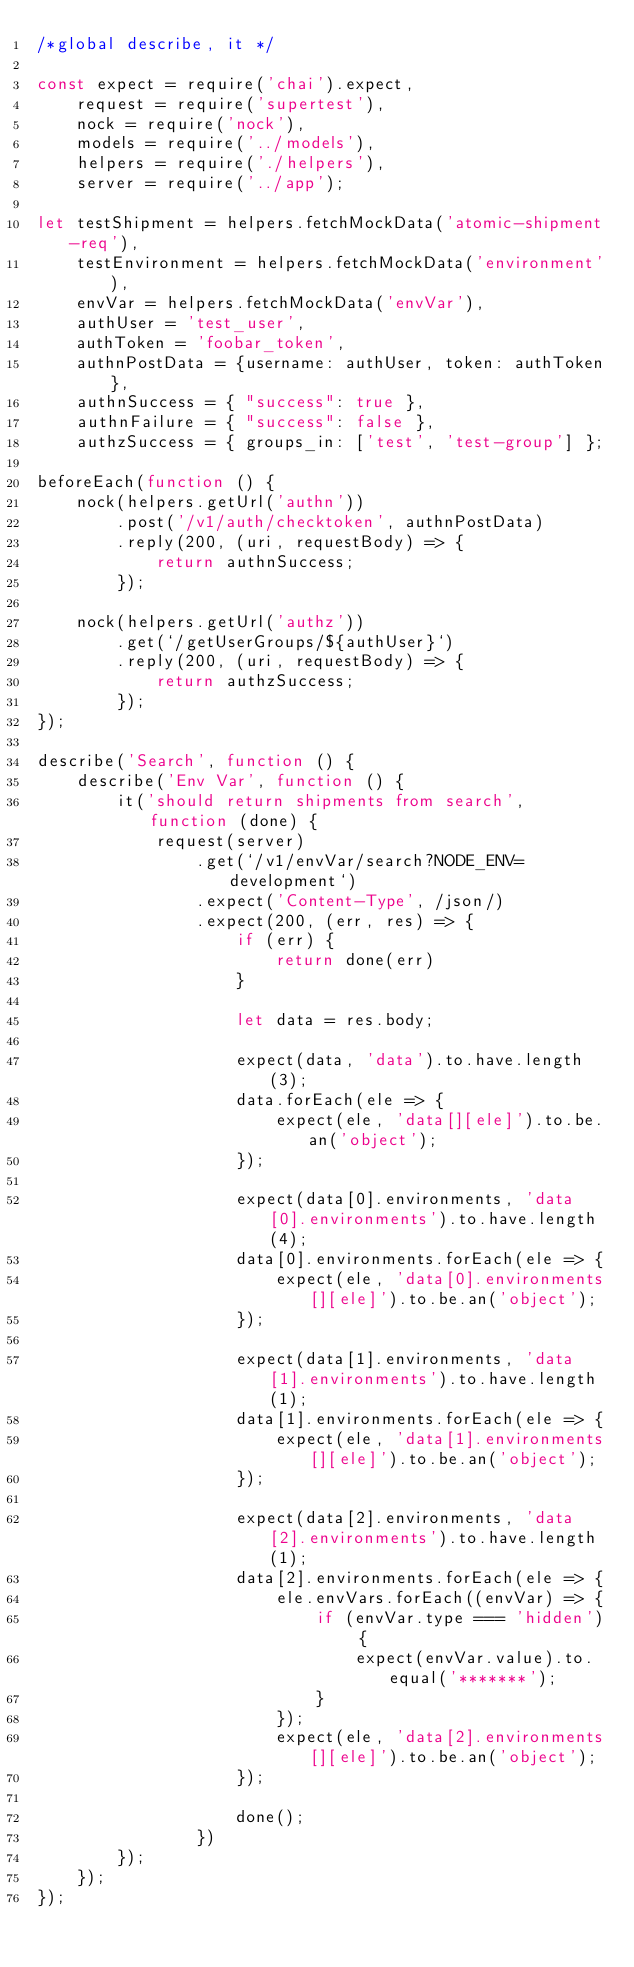Convert code to text. <code><loc_0><loc_0><loc_500><loc_500><_JavaScript_>/*global describe, it */

const expect = require('chai').expect,
    request = require('supertest'),
    nock = require('nock'),
    models = require('../models'),
    helpers = require('./helpers'),
    server = require('../app');

let testShipment = helpers.fetchMockData('atomic-shipment-req'),
    testEnvironment = helpers.fetchMockData('environment'),
    envVar = helpers.fetchMockData('envVar'),
    authUser = 'test_user',
    authToken = 'foobar_token',
    authnPostData = {username: authUser, token: authToken},
    authnSuccess = { "success": true },
    authnFailure = { "success": false },
    authzSuccess = { groups_in: ['test', 'test-group'] };

beforeEach(function () {
    nock(helpers.getUrl('authn'))
        .post('/v1/auth/checktoken', authnPostData)
        .reply(200, (uri, requestBody) => {
            return authnSuccess;
        });

    nock(helpers.getUrl('authz'))
        .get(`/getUserGroups/${authUser}`)
        .reply(200, (uri, requestBody) => {
            return authzSuccess;
        });
});

describe('Search', function () {
    describe('Env Var', function () {
        it('should return shipments from search', function (done) {
            request(server)
                .get(`/v1/envVar/search?NODE_ENV=development`)
                .expect('Content-Type', /json/)
                .expect(200, (err, res) => {
                    if (err) {
                        return done(err)
                    }

                    let data = res.body;

                    expect(data, 'data').to.have.length(3);
                    data.forEach(ele => {
                        expect(ele, 'data[][ele]').to.be.an('object');
                    });

                    expect(data[0].environments, 'data[0].environments').to.have.length(4);
                    data[0].environments.forEach(ele => {
                        expect(ele, 'data[0].environments[][ele]').to.be.an('object');
                    });

                    expect(data[1].environments, 'data[1].environments').to.have.length(1);
                    data[1].environments.forEach(ele => {
                        expect(ele, 'data[1].environments[][ele]').to.be.an('object');
                    });

                    expect(data[2].environments, 'data[2].environments').to.have.length(1);
                    data[2].environments.forEach(ele => {
                        ele.envVars.forEach((envVar) => {
                            if (envVar.type === 'hidden') {
                                expect(envVar.value).to.equal('*******');
                            }
                        });
                        expect(ele, 'data[2].environments[][ele]').to.be.an('object');
                    });

                    done();
                })
        });
    });
});
</code> 